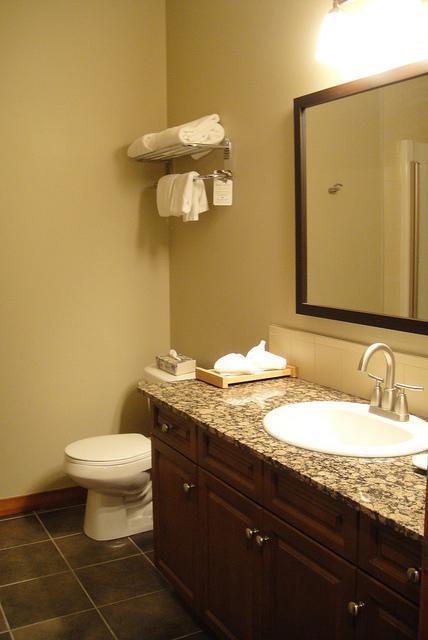How many towels are there?
Give a very brief answer. 4. How many sinks are visible?
Give a very brief answer. 1. 